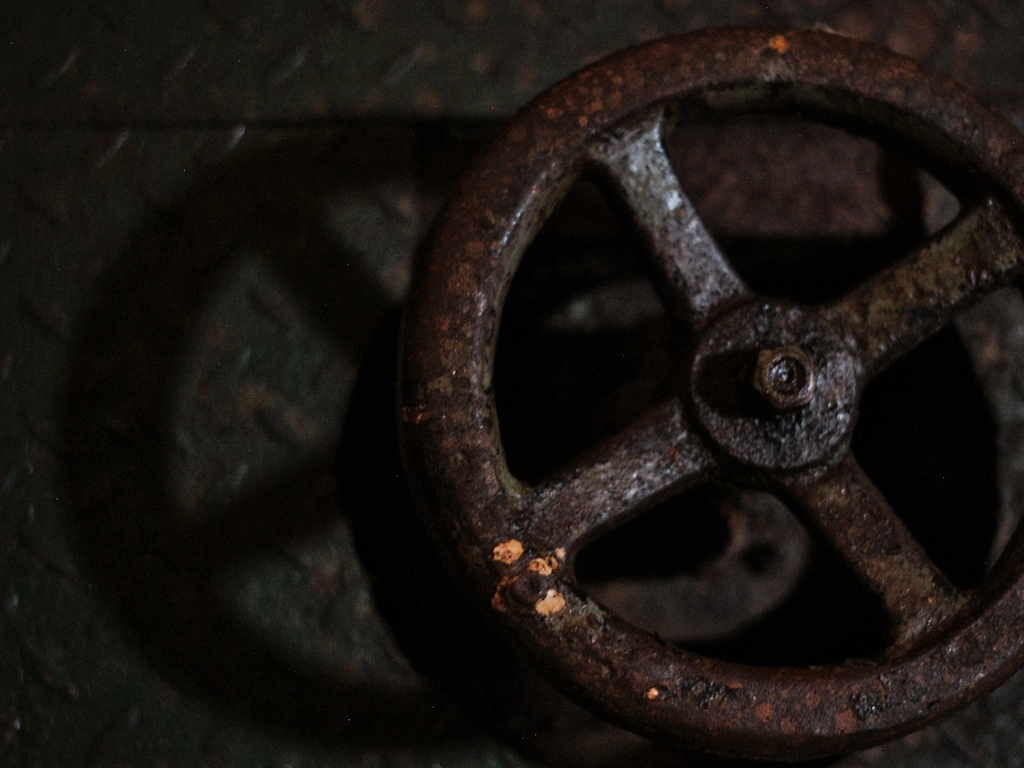Could this object be considered an example of a particular style or movement in design? Yes, it could be related to the steampunk style, which incorporates elements of the industrial era, often characterized by ironwork and mechanical motifs. The aged, metallic aesthetic fits well into the steampunk sensibility, celebrating the craftsmanship of the past. 